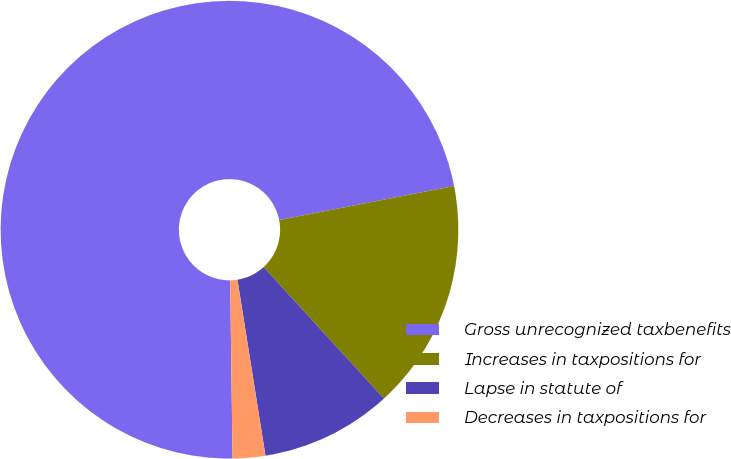Convert chart to OTSL. <chart><loc_0><loc_0><loc_500><loc_500><pie_chart><fcel>Gross unrecognized taxbenefits<fcel>Increases in taxpositions for<fcel>Lapse in statute of<fcel>Decreases in taxpositions for<nl><fcel>72.15%<fcel>16.27%<fcel>9.28%<fcel>2.3%<nl></chart> 